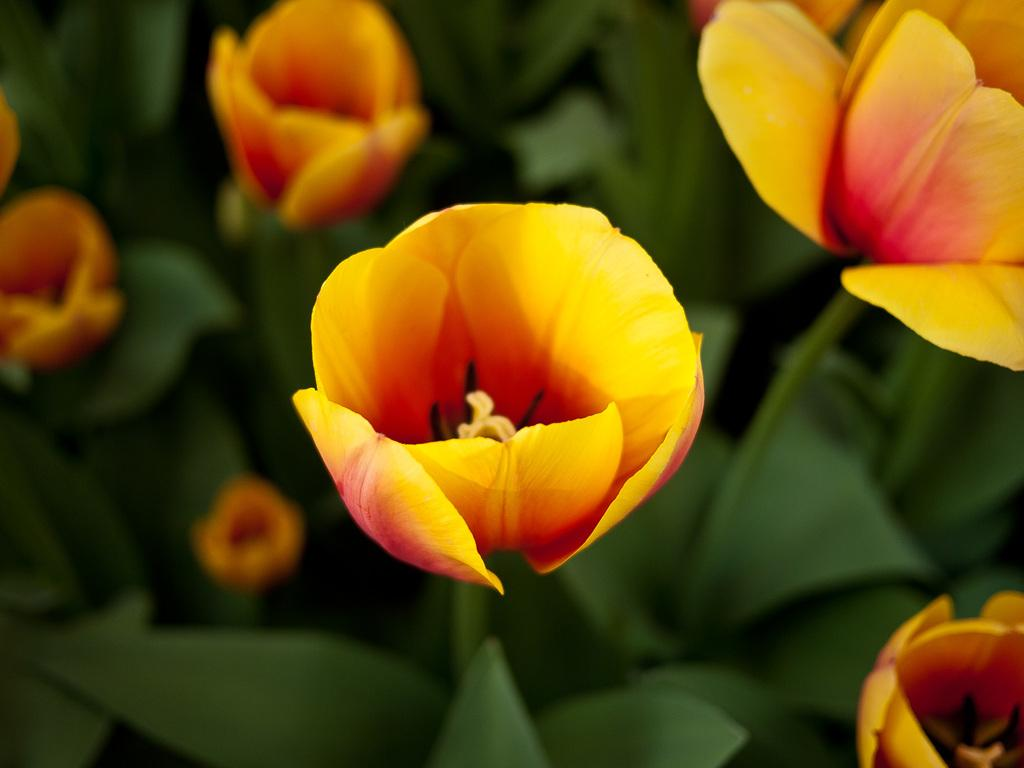What type of plants can be seen in the image? There are flowers in the image. What can be seen in the background of the image? There are leaves in the background of the image. What type of thrill can be experienced by using the calculator in the image? There is no calculator present in the image, so it is not possible to experience any thrill related to a calculator. 